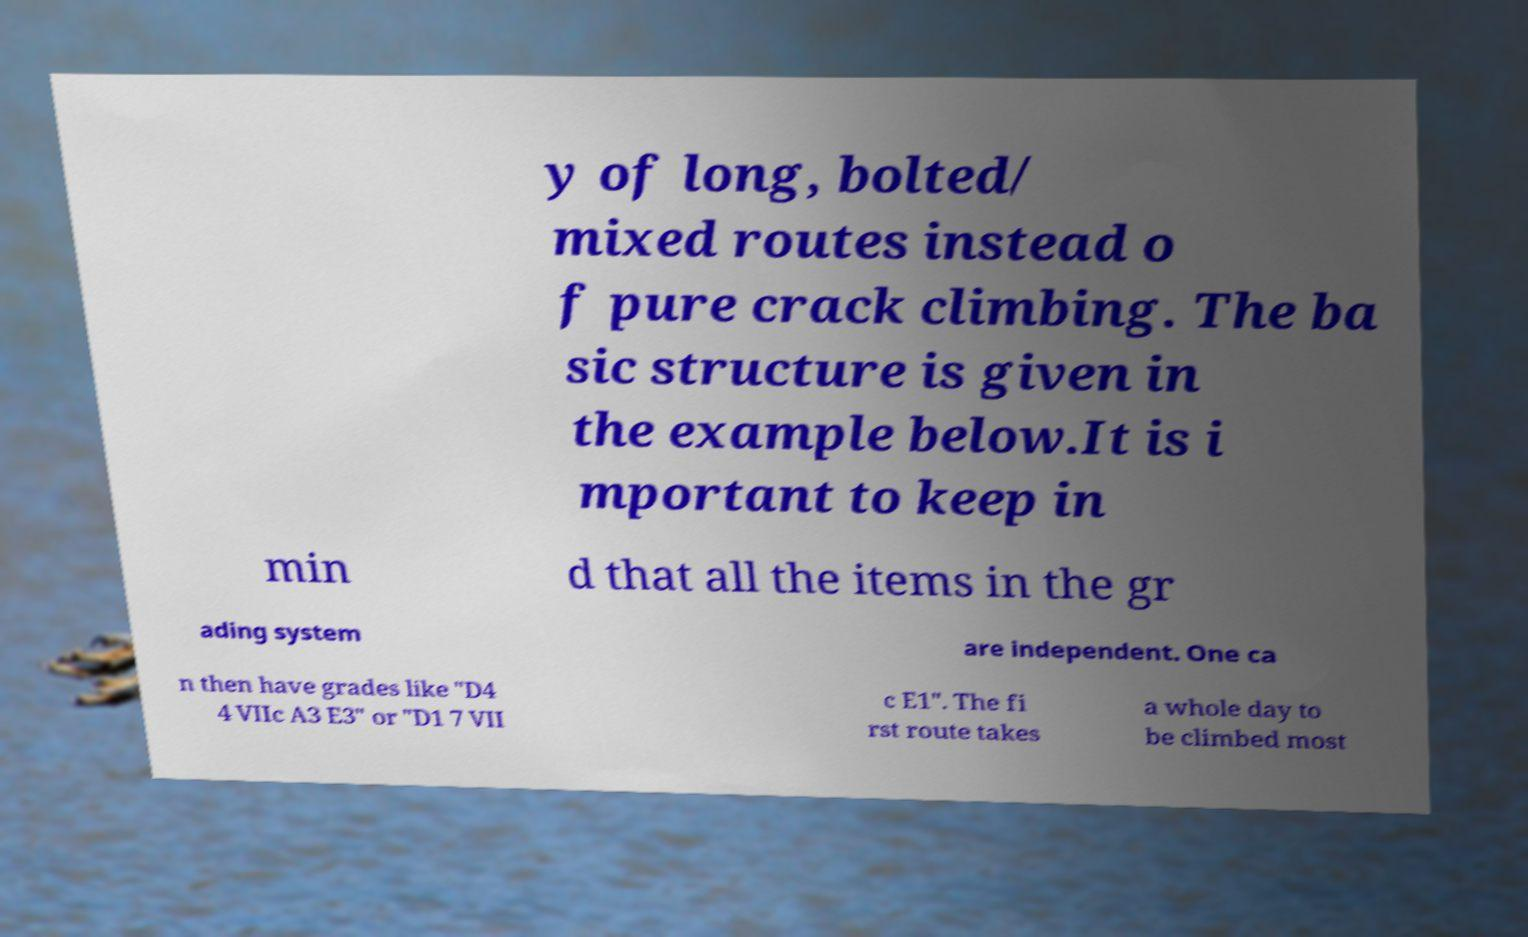I need the written content from this picture converted into text. Can you do that? y of long, bolted/ mixed routes instead o f pure crack climbing. The ba sic structure is given in the example below.It is i mportant to keep in min d that all the items in the gr ading system are independent. One ca n then have grades like "D4 4 VIIc A3 E3" or "D1 7 VII c E1". The fi rst route takes a whole day to be climbed most 